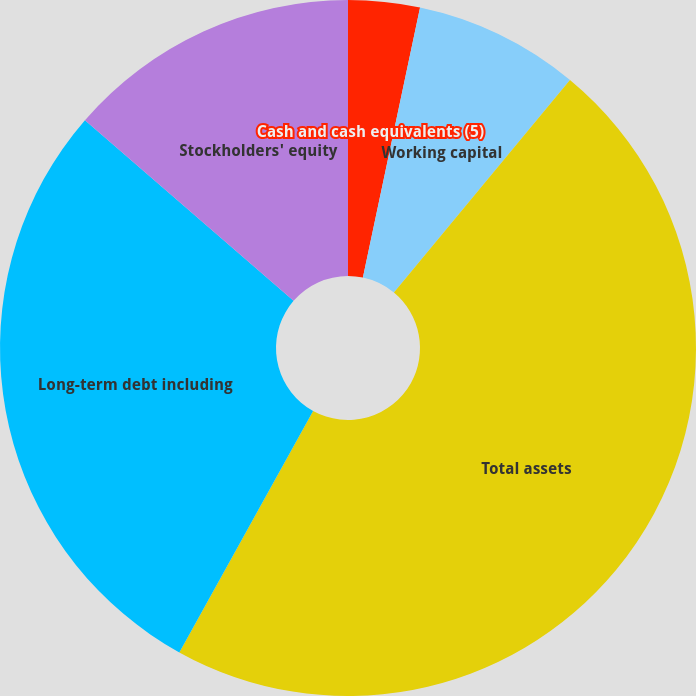Convert chart to OTSL. <chart><loc_0><loc_0><loc_500><loc_500><pie_chart><fcel>Cash and cash equivalents (5)<fcel>Working capital<fcel>Total assets<fcel>Long-term debt including<fcel>Stockholders' equity<nl><fcel>3.32%<fcel>7.69%<fcel>47.05%<fcel>28.31%<fcel>13.64%<nl></chart> 